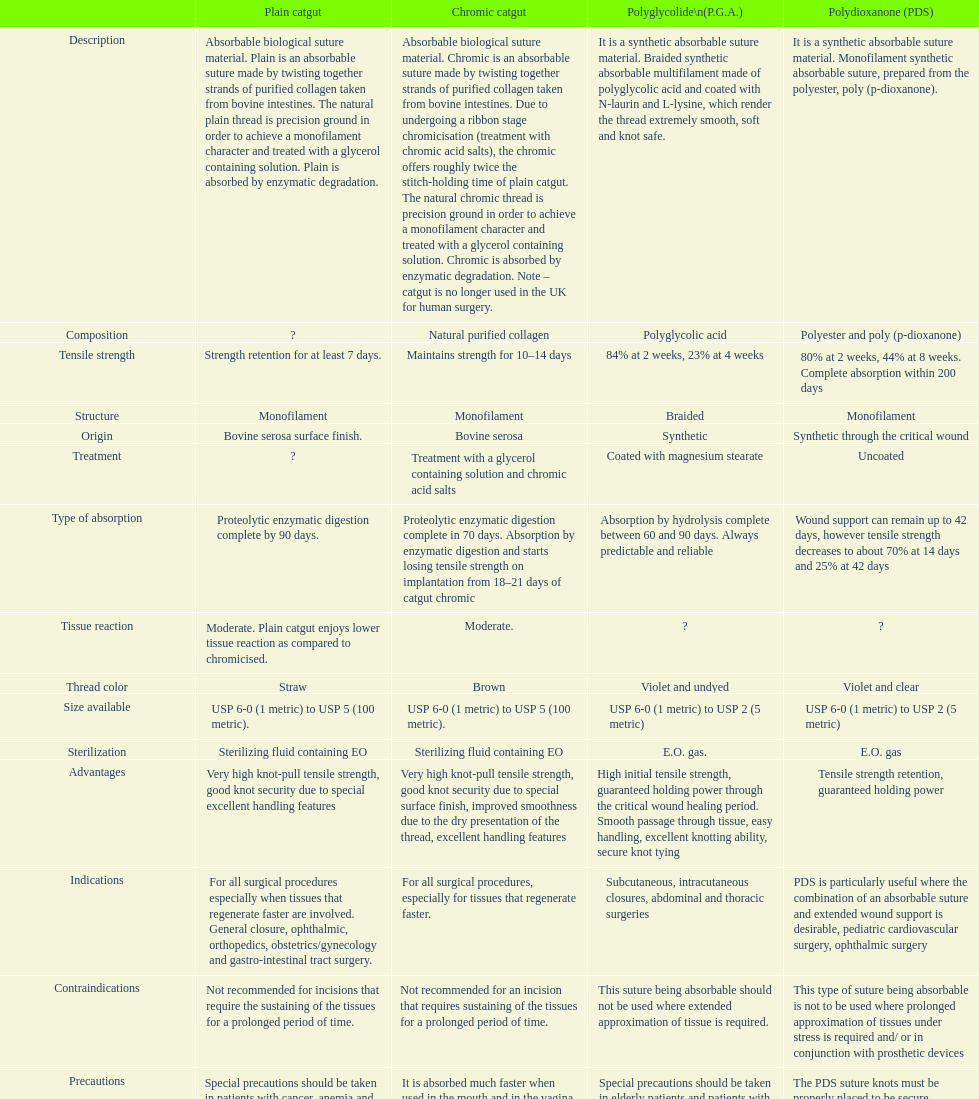What is the structure other than monofilament Braided. 